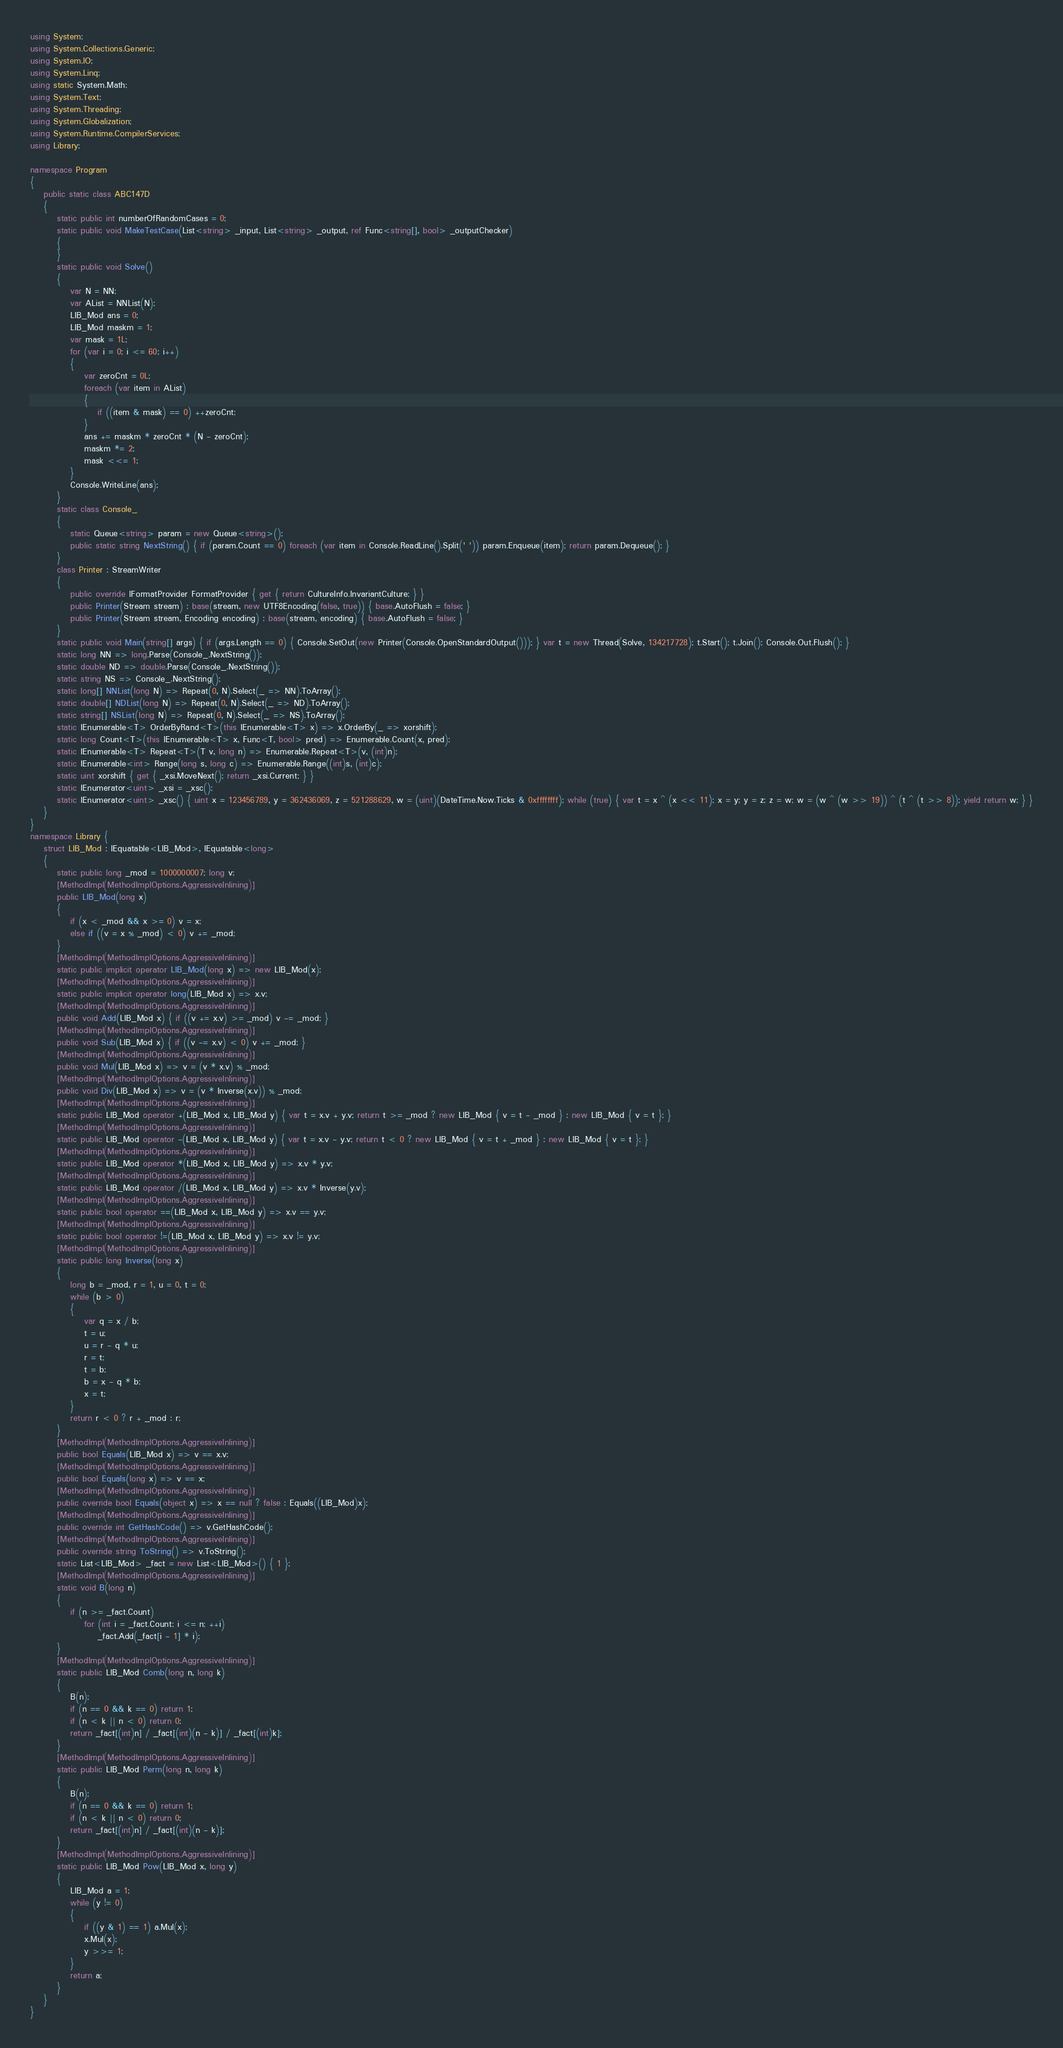<code> <loc_0><loc_0><loc_500><loc_500><_C#_>using System;
using System.Collections.Generic;
using System.IO;
using System.Linq;
using static System.Math;
using System.Text;
using System.Threading;
using System.Globalization;
using System.Runtime.CompilerServices;
using Library;

namespace Program
{
    public static class ABC147D
    {
        static public int numberOfRandomCases = 0;
        static public void MakeTestCase(List<string> _input, List<string> _output, ref Func<string[], bool> _outputChecker)
        {
        }
        static public void Solve()
        {
            var N = NN;
            var AList = NNList(N);
            LIB_Mod ans = 0;
            LIB_Mod maskm = 1;
            var mask = 1L;
            for (var i = 0; i <= 60; i++)
            {
                var zeroCnt = 0L;
                foreach (var item in AList)
                {
                    if ((item & mask) == 0) ++zeroCnt;
                }
                ans += maskm * zeroCnt * (N - zeroCnt);
                maskm *= 2;
                mask <<= 1;
            }
            Console.WriteLine(ans);
        }
        static class Console_
        {
            static Queue<string> param = new Queue<string>();
            public static string NextString() { if (param.Count == 0) foreach (var item in Console.ReadLine().Split(' ')) param.Enqueue(item); return param.Dequeue(); }
        }
        class Printer : StreamWriter
        {
            public override IFormatProvider FormatProvider { get { return CultureInfo.InvariantCulture; } }
            public Printer(Stream stream) : base(stream, new UTF8Encoding(false, true)) { base.AutoFlush = false; }
            public Printer(Stream stream, Encoding encoding) : base(stream, encoding) { base.AutoFlush = false; }
        }
        static public void Main(string[] args) { if (args.Length == 0) { Console.SetOut(new Printer(Console.OpenStandardOutput())); } var t = new Thread(Solve, 134217728); t.Start(); t.Join(); Console.Out.Flush(); }
        static long NN => long.Parse(Console_.NextString());
        static double ND => double.Parse(Console_.NextString());
        static string NS => Console_.NextString();
        static long[] NNList(long N) => Repeat(0, N).Select(_ => NN).ToArray();
        static double[] NDList(long N) => Repeat(0, N).Select(_ => ND).ToArray();
        static string[] NSList(long N) => Repeat(0, N).Select(_ => NS).ToArray();
        static IEnumerable<T> OrderByRand<T>(this IEnumerable<T> x) => x.OrderBy(_ => xorshift);
        static long Count<T>(this IEnumerable<T> x, Func<T, bool> pred) => Enumerable.Count(x, pred);
        static IEnumerable<T> Repeat<T>(T v, long n) => Enumerable.Repeat<T>(v, (int)n);
        static IEnumerable<int> Range(long s, long c) => Enumerable.Range((int)s, (int)c);
        static uint xorshift { get { _xsi.MoveNext(); return _xsi.Current; } }
        static IEnumerator<uint> _xsi = _xsc();
        static IEnumerator<uint> _xsc() { uint x = 123456789, y = 362436069, z = 521288629, w = (uint)(DateTime.Now.Ticks & 0xffffffff); while (true) { var t = x ^ (x << 11); x = y; y = z; z = w; w = (w ^ (w >> 19)) ^ (t ^ (t >> 8)); yield return w; } }
    }
}
namespace Library {
    struct LIB_Mod : IEquatable<LIB_Mod>, IEquatable<long>
    {
        static public long _mod = 1000000007; long v;
        [MethodImpl(MethodImplOptions.AggressiveInlining)]
        public LIB_Mod(long x)
        {
            if (x < _mod && x >= 0) v = x;
            else if ((v = x % _mod) < 0) v += _mod;
        }
        [MethodImpl(MethodImplOptions.AggressiveInlining)]
        static public implicit operator LIB_Mod(long x) => new LIB_Mod(x);
        [MethodImpl(MethodImplOptions.AggressiveInlining)]
        static public implicit operator long(LIB_Mod x) => x.v;
        [MethodImpl(MethodImplOptions.AggressiveInlining)]
        public void Add(LIB_Mod x) { if ((v += x.v) >= _mod) v -= _mod; }
        [MethodImpl(MethodImplOptions.AggressiveInlining)]
        public void Sub(LIB_Mod x) { if ((v -= x.v) < 0) v += _mod; }
        [MethodImpl(MethodImplOptions.AggressiveInlining)]
        public void Mul(LIB_Mod x) => v = (v * x.v) % _mod;
        [MethodImpl(MethodImplOptions.AggressiveInlining)]
        public void Div(LIB_Mod x) => v = (v * Inverse(x.v)) % _mod;
        [MethodImpl(MethodImplOptions.AggressiveInlining)]
        static public LIB_Mod operator +(LIB_Mod x, LIB_Mod y) { var t = x.v + y.v; return t >= _mod ? new LIB_Mod { v = t - _mod } : new LIB_Mod { v = t }; }
        [MethodImpl(MethodImplOptions.AggressiveInlining)]
        static public LIB_Mod operator -(LIB_Mod x, LIB_Mod y) { var t = x.v - y.v; return t < 0 ? new LIB_Mod { v = t + _mod } : new LIB_Mod { v = t }; }
        [MethodImpl(MethodImplOptions.AggressiveInlining)]
        static public LIB_Mod operator *(LIB_Mod x, LIB_Mod y) => x.v * y.v;
        [MethodImpl(MethodImplOptions.AggressiveInlining)]
        static public LIB_Mod operator /(LIB_Mod x, LIB_Mod y) => x.v * Inverse(y.v);
        [MethodImpl(MethodImplOptions.AggressiveInlining)]
        static public bool operator ==(LIB_Mod x, LIB_Mod y) => x.v == y.v;
        [MethodImpl(MethodImplOptions.AggressiveInlining)]
        static public bool operator !=(LIB_Mod x, LIB_Mod y) => x.v != y.v;
        [MethodImpl(MethodImplOptions.AggressiveInlining)]
        static public long Inverse(long x)
        {
            long b = _mod, r = 1, u = 0, t = 0;
            while (b > 0)
            {
                var q = x / b;
                t = u;
                u = r - q * u;
                r = t;
                t = b;
                b = x - q * b;
                x = t;
            }
            return r < 0 ? r + _mod : r;
        }
        [MethodImpl(MethodImplOptions.AggressiveInlining)]
        public bool Equals(LIB_Mod x) => v == x.v;
        [MethodImpl(MethodImplOptions.AggressiveInlining)]
        public bool Equals(long x) => v == x;
        [MethodImpl(MethodImplOptions.AggressiveInlining)]
        public override bool Equals(object x) => x == null ? false : Equals((LIB_Mod)x);
        [MethodImpl(MethodImplOptions.AggressiveInlining)]
        public override int GetHashCode() => v.GetHashCode();
        [MethodImpl(MethodImplOptions.AggressiveInlining)]
        public override string ToString() => v.ToString();
        static List<LIB_Mod> _fact = new List<LIB_Mod>() { 1 };
        [MethodImpl(MethodImplOptions.AggressiveInlining)]
        static void B(long n)
        {
            if (n >= _fact.Count)
                for (int i = _fact.Count; i <= n; ++i)
                    _fact.Add(_fact[i - 1] * i);
        }
        [MethodImpl(MethodImplOptions.AggressiveInlining)]
        static public LIB_Mod Comb(long n, long k)
        {
            B(n);
            if (n == 0 && k == 0) return 1;
            if (n < k || n < 0) return 0;
            return _fact[(int)n] / _fact[(int)(n - k)] / _fact[(int)k];
        }
        [MethodImpl(MethodImplOptions.AggressiveInlining)]
        static public LIB_Mod Perm(long n, long k)
        {
            B(n);
            if (n == 0 && k == 0) return 1;
            if (n < k || n < 0) return 0;
            return _fact[(int)n] / _fact[(int)(n - k)];
        }
        [MethodImpl(MethodImplOptions.AggressiveInlining)]
        static public LIB_Mod Pow(LIB_Mod x, long y)
        {
            LIB_Mod a = 1;
            while (y != 0)
            {
                if ((y & 1) == 1) a.Mul(x);
                x.Mul(x);
                y >>= 1;
            }
            return a;
        }
    }
}
</code> 